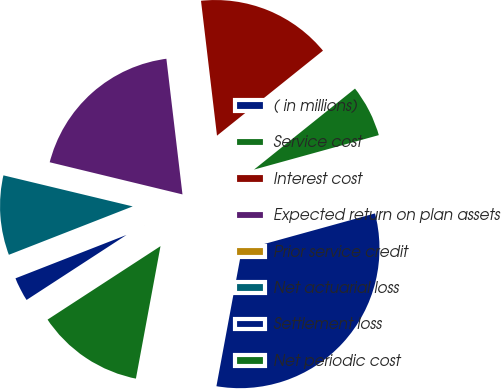<chart> <loc_0><loc_0><loc_500><loc_500><pie_chart><fcel>( in millions)<fcel>Service cost<fcel>Interest cost<fcel>Expected return on plan assets<fcel>Prior service credit<fcel>Net actuarial loss<fcel>Settlement loss<fcel>Net periodic cost<nl><fcel>32.21%<fcel>6.47%<fcel>16.12%<fcel>19.34%<fcel>0.03%<fcel>9.68%<fcel>3.25%<fcel>12.9%<nl></chart> 